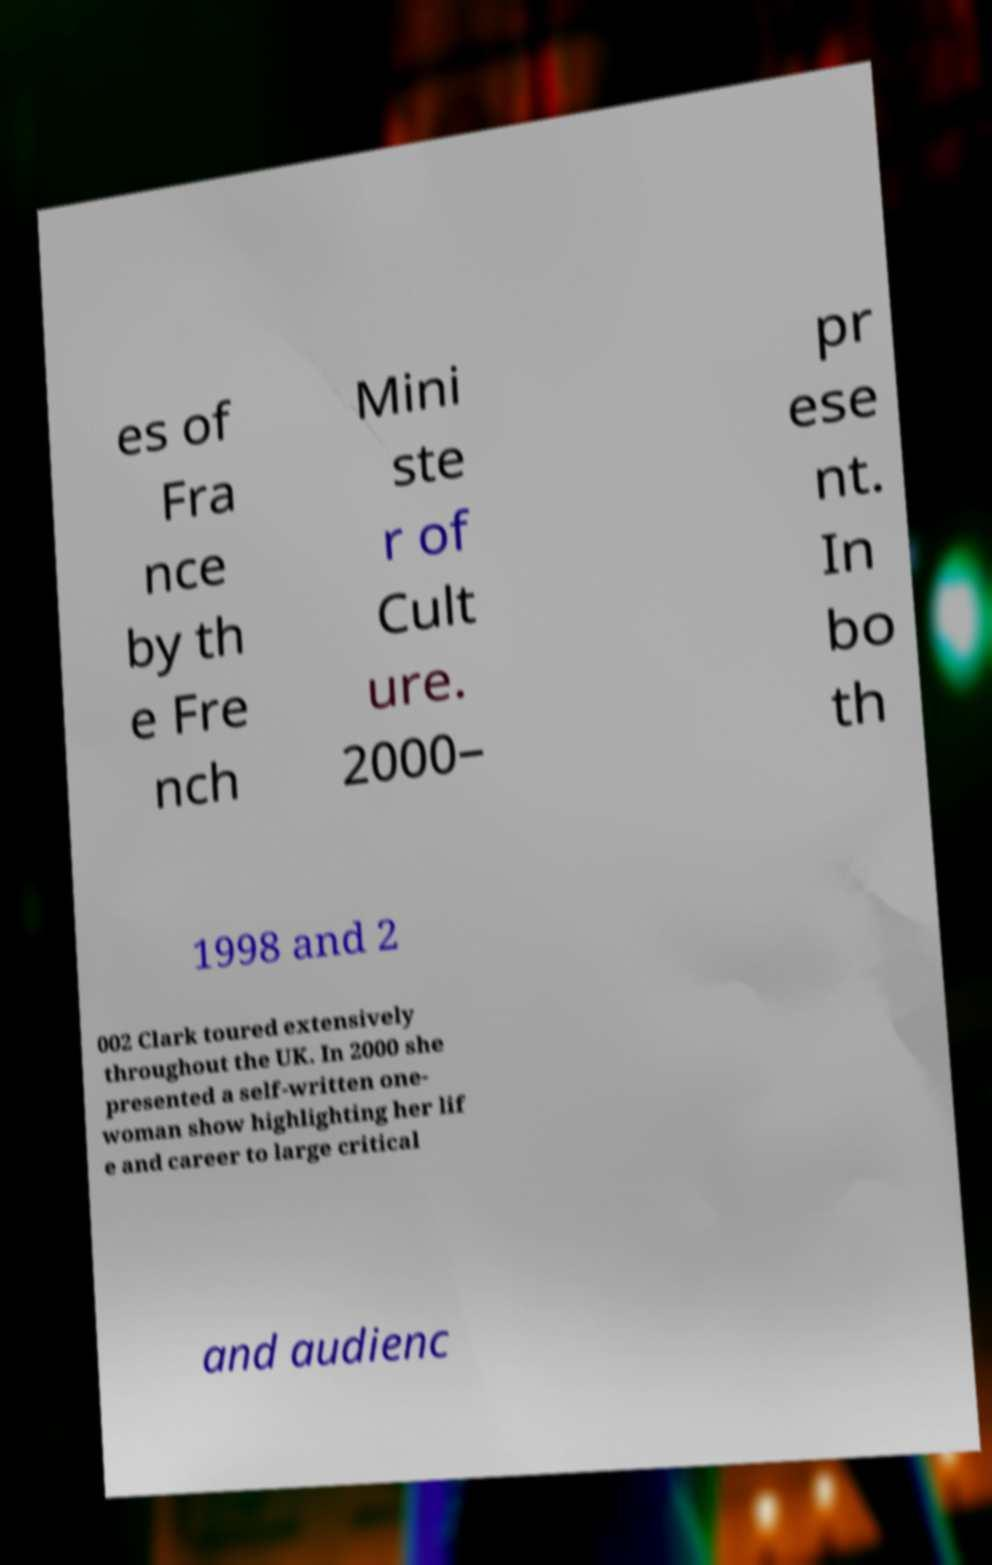Could you extract and type out the text from this image? es of Fra nce by th e Fre nch Mini ste r of Cult ure. 2000– pr ese nt. In bo th 1998 and 2 002 Clark toured extensively throughout the UK. In 2000 she presented a self-written one- woman show highlighting her lif e and career to large critical and audienc 